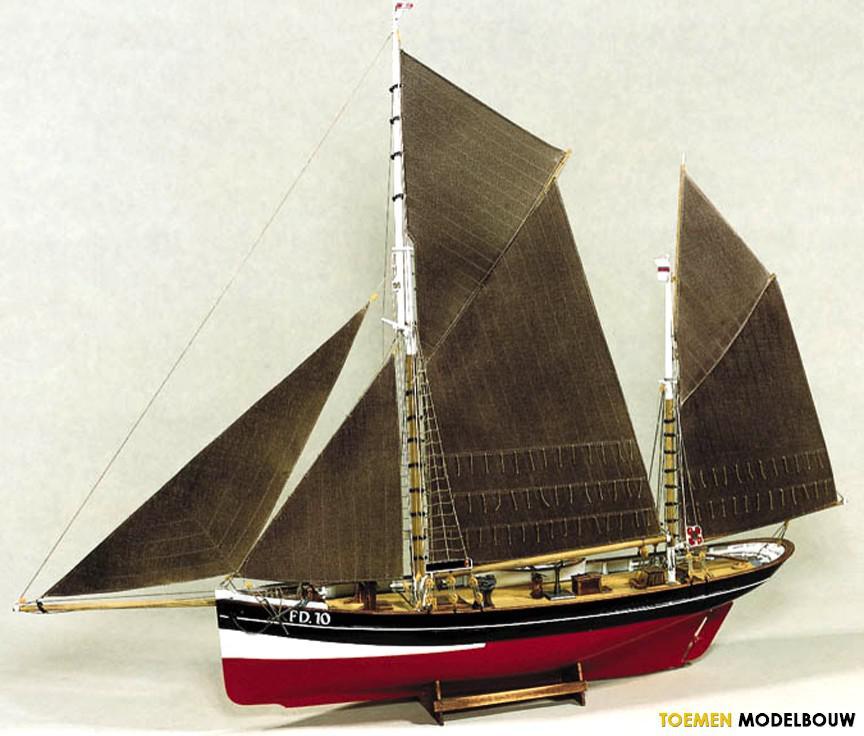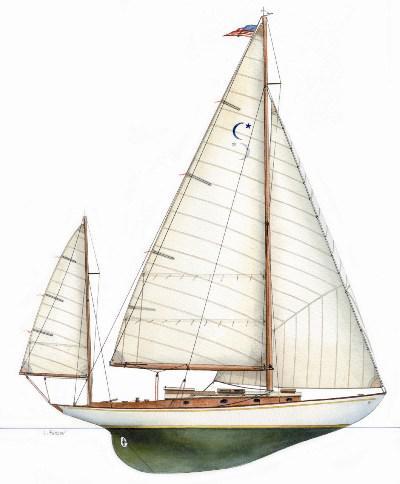The first image is the image on the left, the second image is the image on the right. For the images shown, is this caption "Two sailboat models are sitting on matching stands." true? Answer yes or no. No. The first image is the image on the left, the second image is the image on the right. Evaluate the accuracy of this statement regarding the images: "Right image features a boat with only brown sails.". Is it true? Answer yes or no. No. 